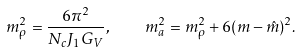<formula> <loc_0><loc_0><loc_500><loc_500>m ^ { 2 } _ { \rho } = \frac { 6 \pi ^ { 2 } } { N _ { c } J _ { 1 } G _ { V } } , \quad m ^ { 2 } _ { a } = m ^ { 2 } _ { \rho } + 6 ( m - \hat { m } ) ^ { 2 } .</formula> 